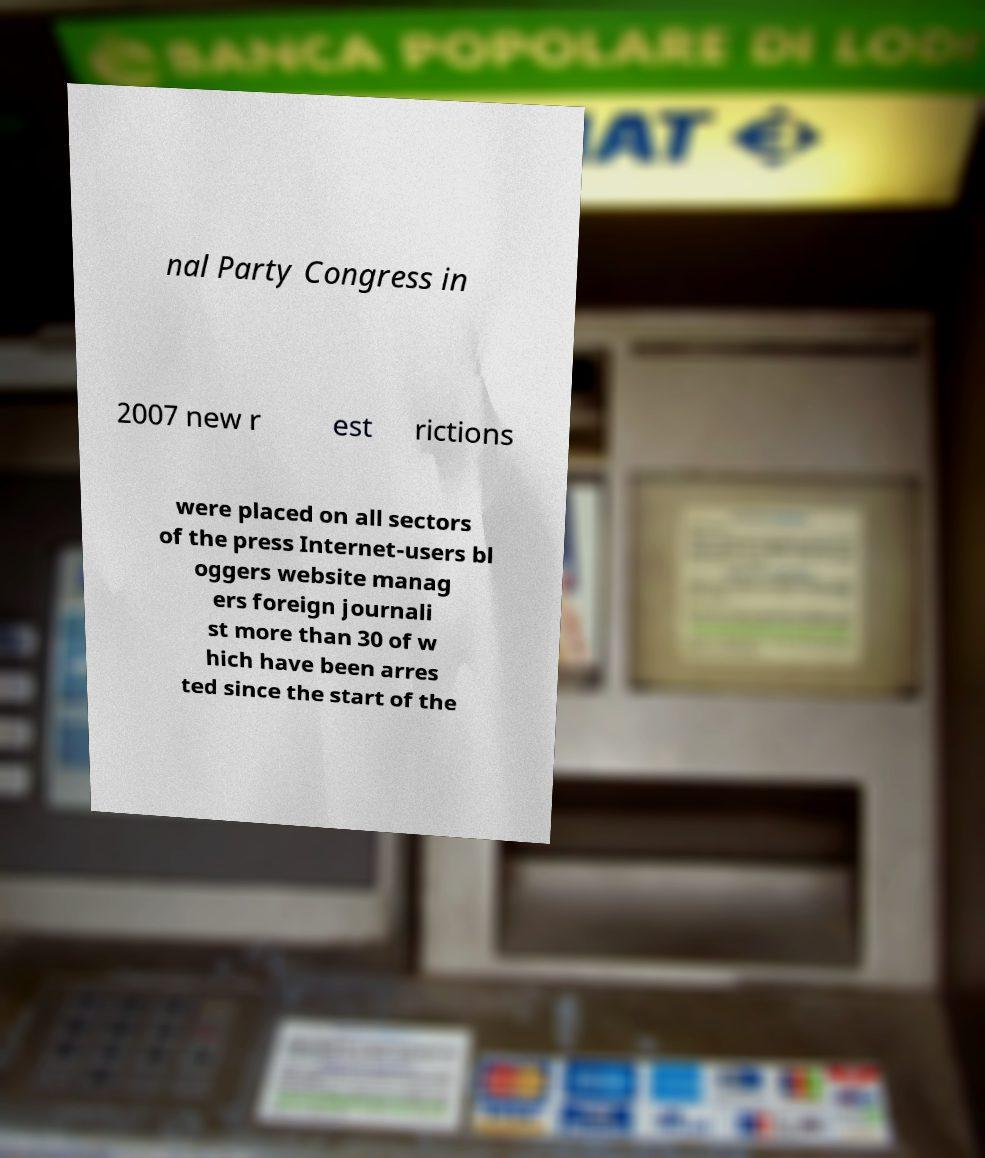Can you read and provide the text displayed in the image?This photo seems to have some interesting text. Can you extract and type it out for me? nal Party Congress in 2007 new r est rictions were placed on all sectors of the press Internet-users bl oggers website manag ers foreign journali st more than 30 of w hich have been arres ted since the start of the 